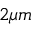Convert formula to latex. <formula><loc_0><loc_0><loc_500><loc_500>2 \mu m</formula> 